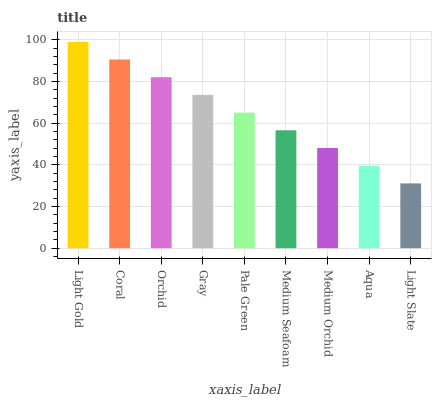Is Coral the minimum?
Answer yes or no. No. Is Coral the maximum?
Answer yes or no. No. Is Light Gold greater than Coral?
Answer yes or no. Yes. Is Coral less than Light Gold?
Answer yes or no. Yes. Is Coral greater than Light Gold?
Answer yes or no. No. Is Light Gold less than Coral?
Answer yes or no. No. Is Pale Green the high median?
Answer yes or no. Yes. Is Pale Green the low median?
Answer yes or no. Yes. Is Light Slate the high median?
Answer yes or no. No. Is Coral the low median?
Answer yes or no. No. 